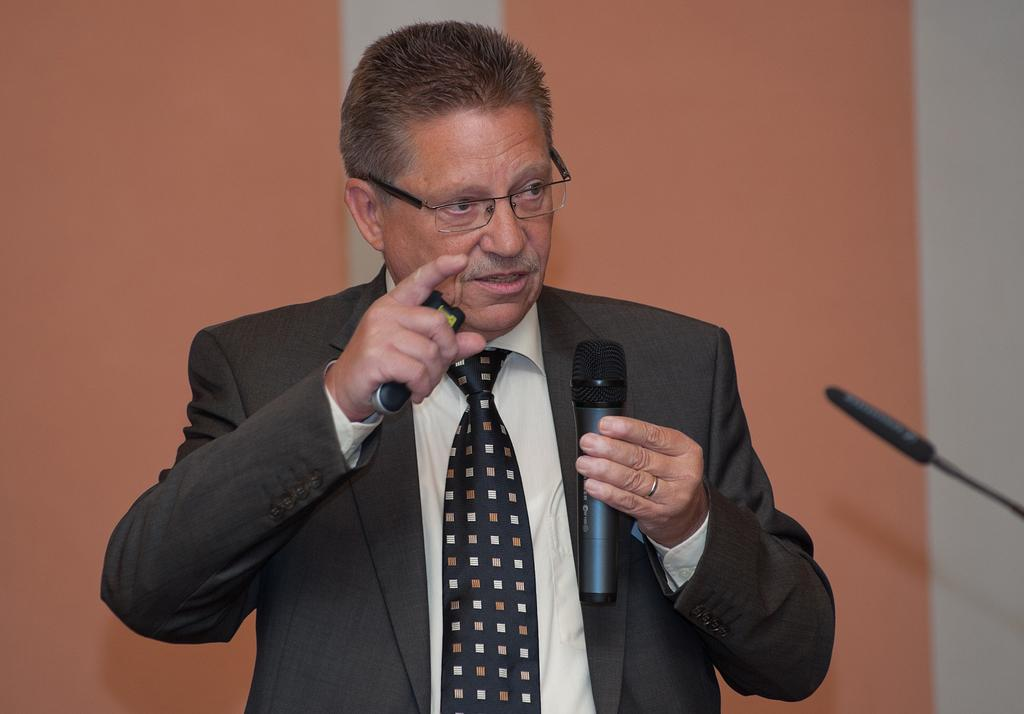What is the main subject of the image? The main subject of the image is a man. What is the man wearing? The man is wearing a blazer, a tie, and spectacles. What is the man holding in his hand? The man is holding a mic in one hand. What is the man doing in the image? The man is talking. What can be seen in the background of the image? There is a wall in the background of the image. How many brothers does the man have in the image? There is no information about the man's brothers in the image. What type of calculator is the man using in the image? There is no calculator present in the image. 